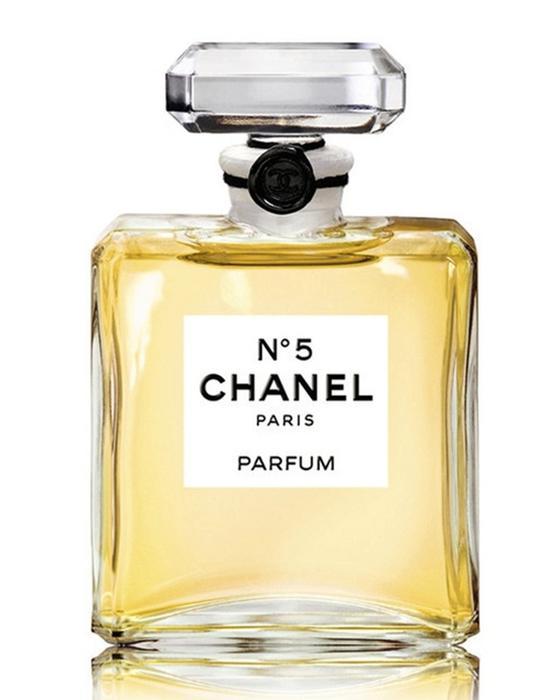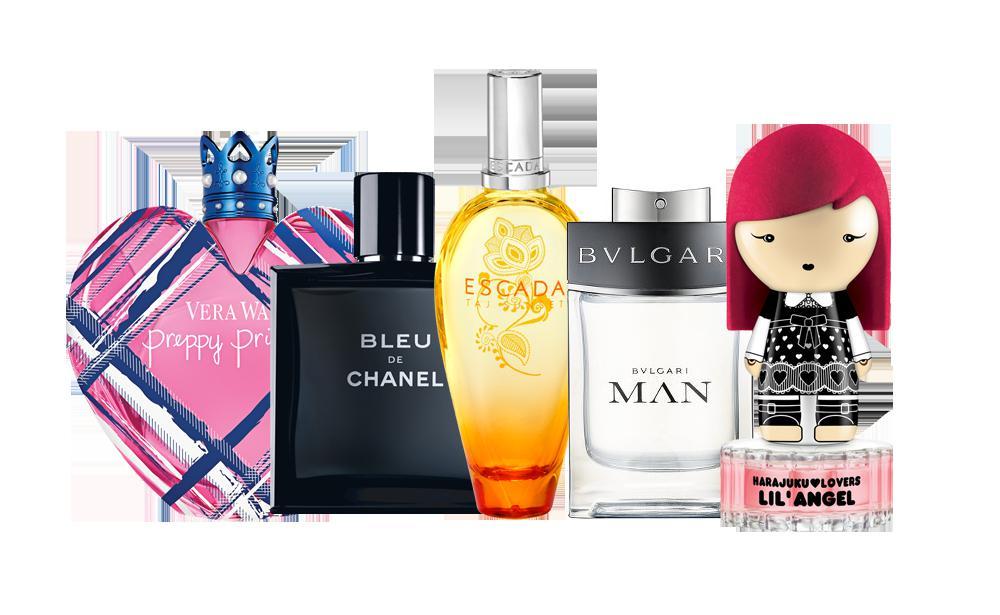The first image is the image on the left, the second image is the image on the right. Assess this claim about the two images: "There is at least one perfume bottle being displayed in the center of the images.". Correct or not? Answer yes or no. Yes. The first image is the image on the left, the second image is the image on the right. Assess this claim about the two images: "There is a single squared full chanel number 5 perfume bottle in at least one image.". Correct or not? Answer yes or no. Yes. 